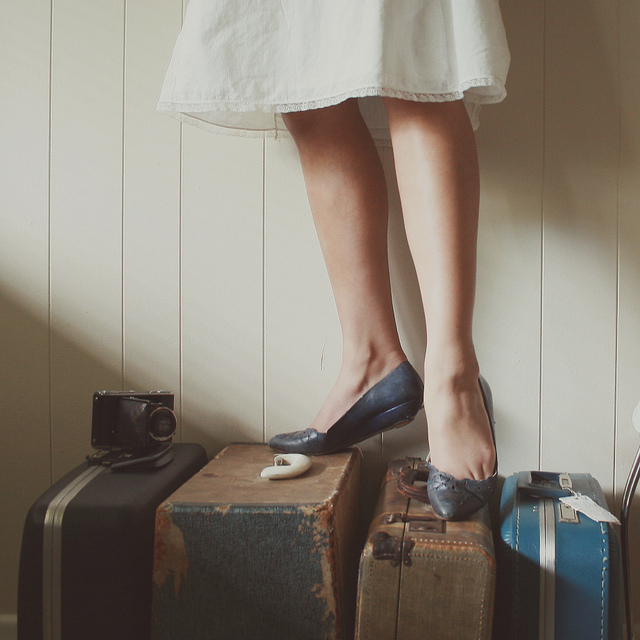How many motorcycles are shown? The image does not depict any motorcycles. Instead, it captures a more intimate setting, focusing on a person's legs while standing on various pieces of vintage luggage with a classic camera resting to the side – suggesting themes of travel and nostalgia. 